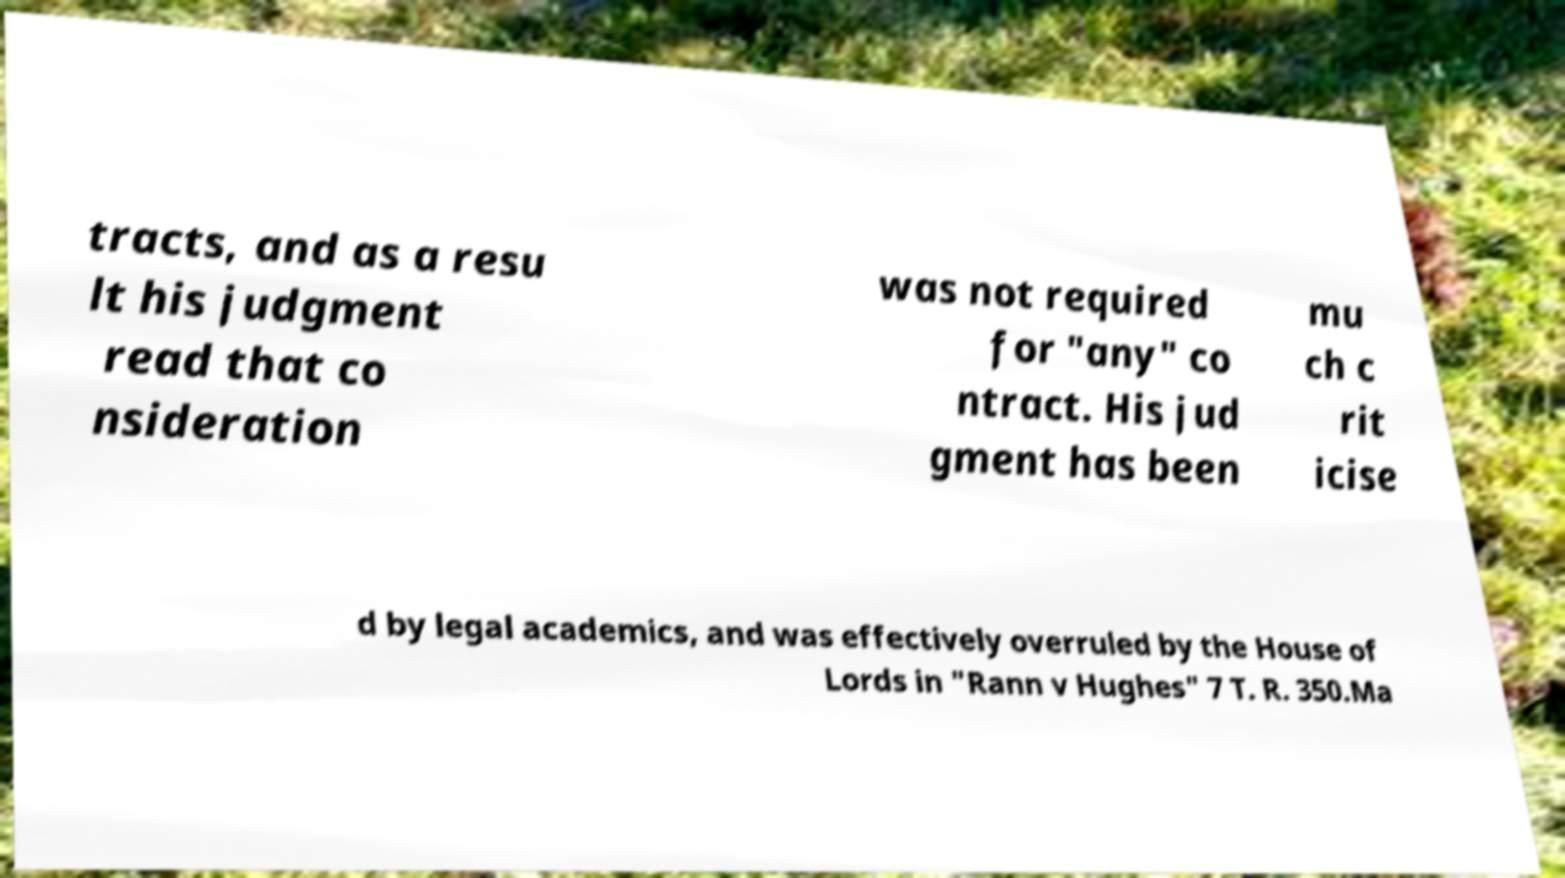I need the written content from this picture converted into text. Can you do that? tracts, and as a resu lt his judgment read that co nsideration was not required for "any" co ntract. His jud gment has been mu ch c rit icise d by legal academics, and was effectively overruled by the House of Lords in "Rann v Hughes" 7 T. R. 350.Ma 